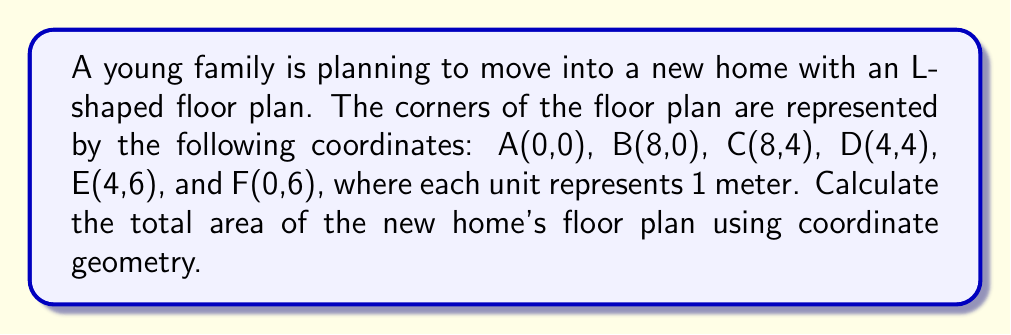Give your solution to this math problem. To calculate the area of the L-shaped floor plan, we can divide it into two rectangles and use the formula for the area of a rectangle: $A = length \times width$

1. Divide the L-shape into two rectangles:
   Rectangle 1: ABCD
   Rectangle 2: DEFF

2. Calculate the area of Rectangle 1 (ABCD):
   Length = $x_B - x_A = 8 - 0 = 8$ meters
   Width = $y_C - y_B = 4 - 0 = 4$ meters
   Area of Rectangle 1 = $8 \times 4 = 32$ square meters

3. Calculate the area of Rectangle 2 (DEFF):
   Length = $x_D - x_F = 4 - 0 = 4$ meters
   Width = $y_E - y_D = 6 - 4 = 2$ meters
   Area of Rectangle 2 = $4 \times 2 = 8$ square meters

4. Calculate the total area:
   Total Area = Area of Rectangle 1 + Area of Rectangle 2
   Total Area = $32 + 8 = 40$ square meters

Therefore, the total area of the new home's floor plan is 40 square meters.
Answer: 40 m² 